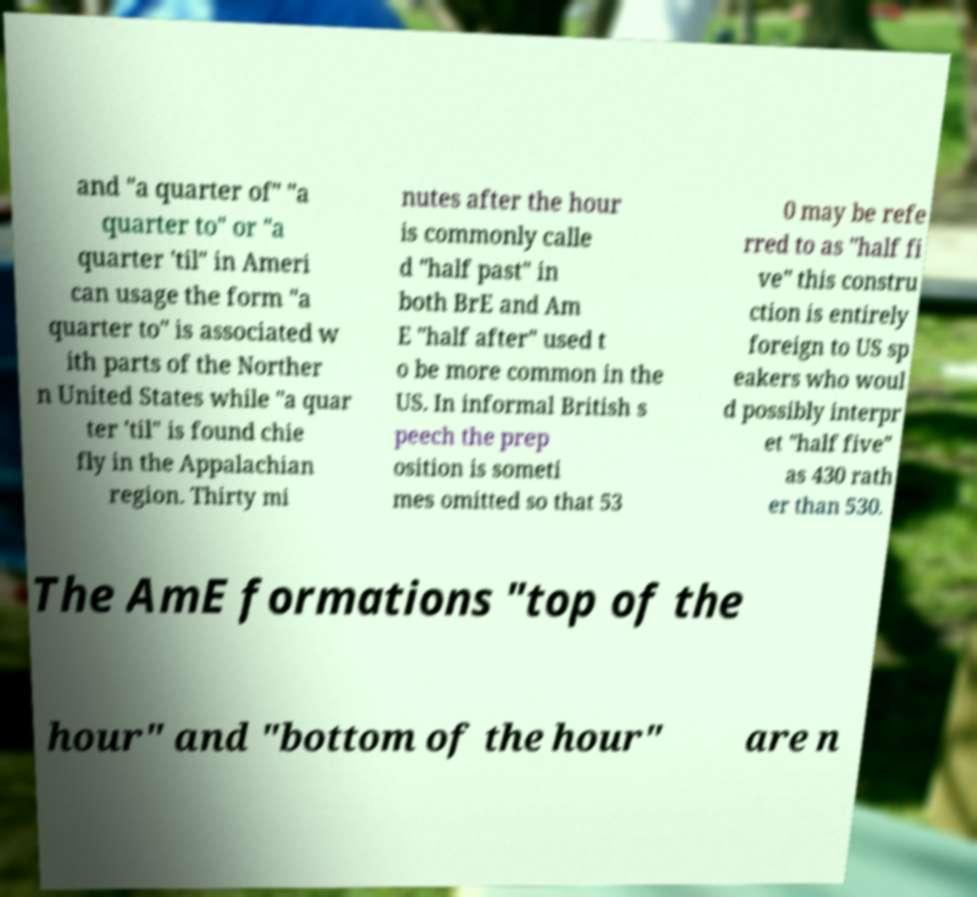What messages or text are displayed in this image? I need them in a readable, typed format. and "a quarter of" "a quarter to" or "a quarter 'til" in Ameri can usage the form "a quarter to" is associated w ith parts of the Norther n United States while "a quar ter 'til" is found chie fly in the Appalachian region. Thirty mi nutes after the hour is commonly calle d "half past" in both BrE and Am E "half after" used t o be more common in the US. In informal British s peech the prep osition is someti mes omitted so that 53 0 may be refe rred to as "half fi ve" this constru ction is entirely foreign to US sp eakers who woul d possibly interpr et "half five" as 430 rath er than 530. The AmE formations "top of the hour" and "bottom of the hour" are n 